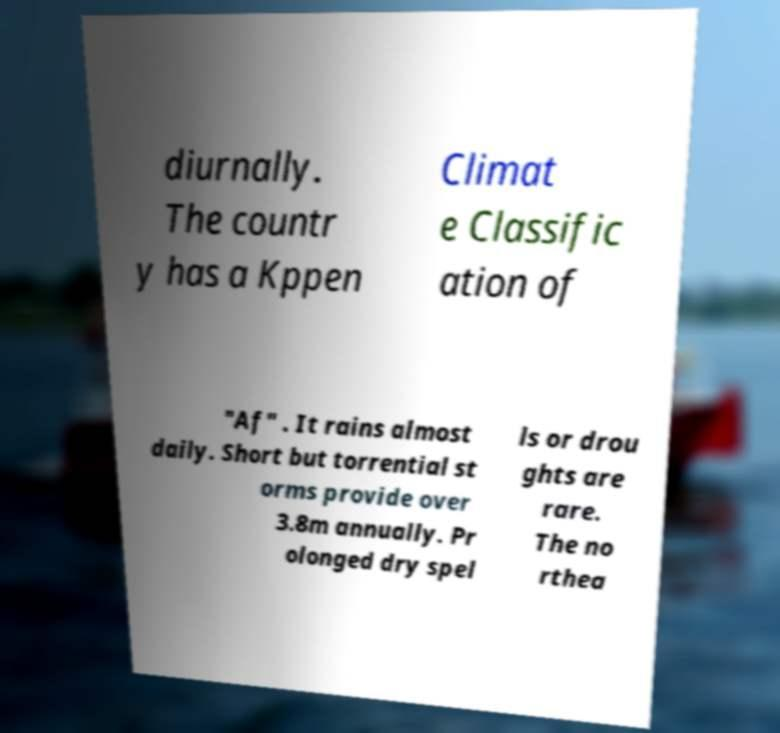For documentation purposes, I need the text within this image transcribed. Could you provide that? diurnally. The countr y has a Kppen Climat e Classific ation of "Af" . It rains almost daily. Short but torrential st orms provide over 3.8m annually. Pr olonged dry spel ls or drou ghts are rare. The no rthea 